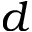Convert formula to latex. <formula><loc_0><loc_0><loc_500><loc_500>d</formula> 